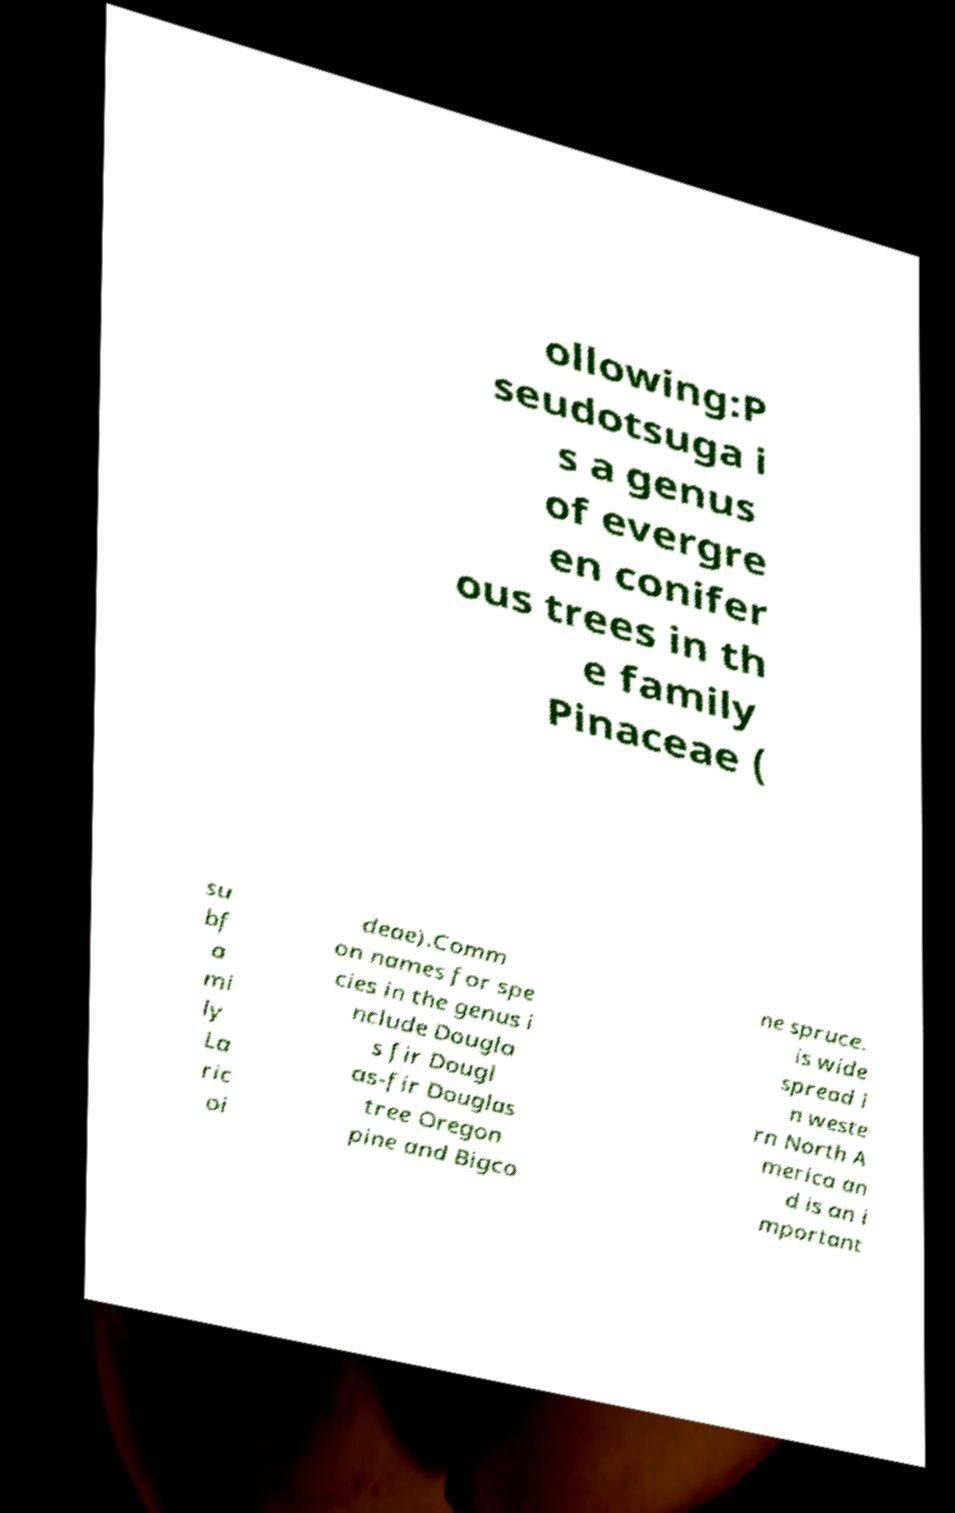Can you read and provide the text displayed in the image?This photo seems to have some interesting text. Can you extract and type it out for me? ollowing:P seudotsuga i s a genus of evergre en conifer ous trees in th e family Pinaceae ( su bf a mi ly La ric oi deae).Comm on names for spe cies in the genus i nclude Dougla s fir Dougl as-fir Douglas tree Oregon pine and Bigco ne spruce. is wide spread i n weste rn North A merica an d is an i mportant 